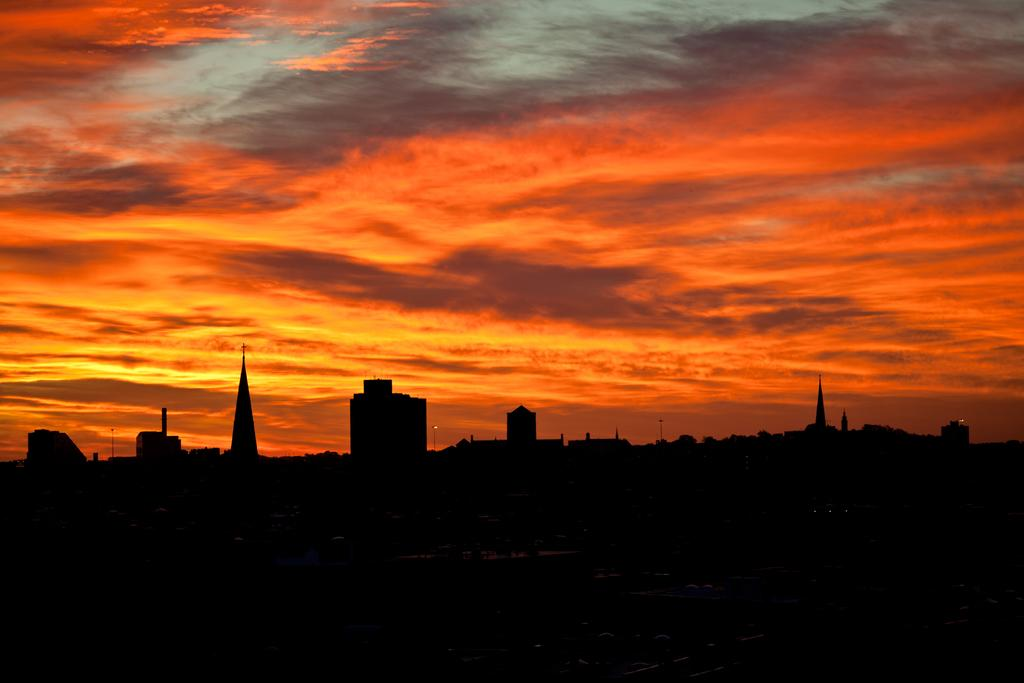What structures are visible in the image? There are buildings in the image. What is the color of the sky in the image? The sky is red in color. Can you see a cub playing with a wheel in the image? There is no cub or wheel present in the image. Is there a veil covering any part of the buildings in the image? There is no mention of a veil or any object covering the buildings in the image. 